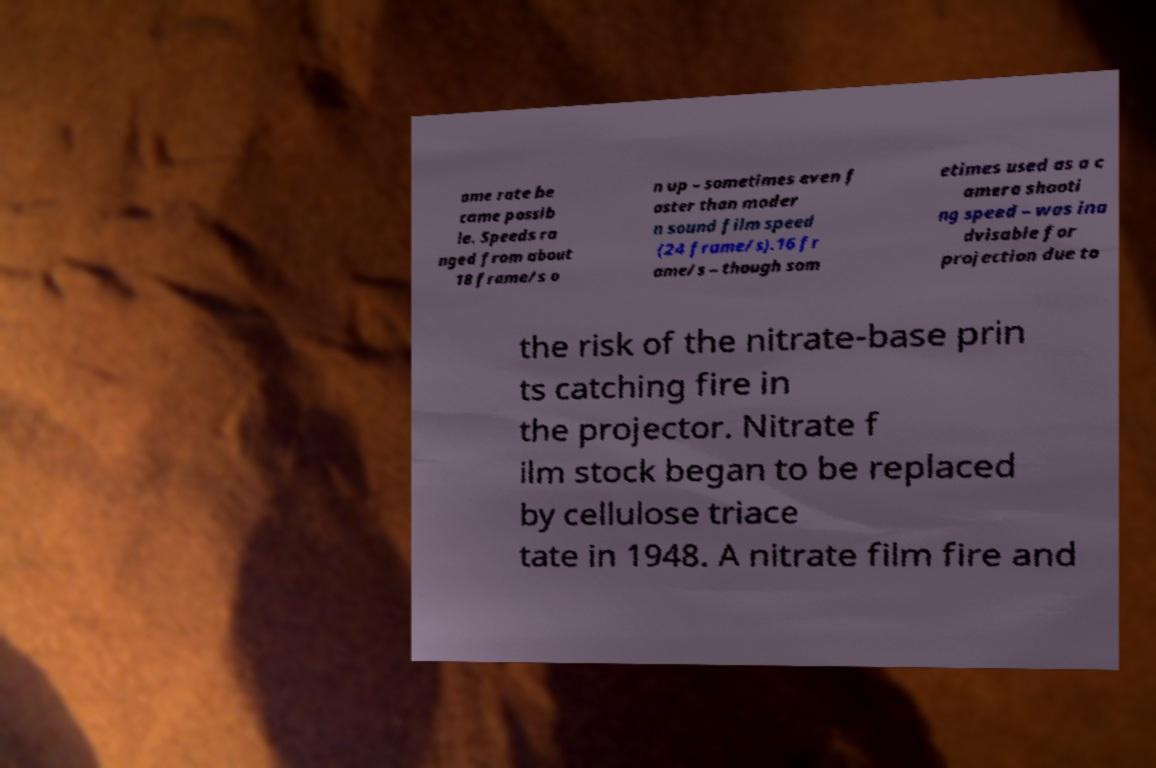Can you read and provide the text displayed in the image?This photo seems to have some interesting text. Can you extract and type it out for me? ame rate be came possib le. Speeds ra nged from about 18 frame/s o n up – sometimes even f aster than moder n sound film speed (24 frame/s).16 fr ame/s – though som etimes used as a c amera shooti ng speed – was ina dvisable for projection due to the risk of the nitrate-base prin ts catching fire in the projector. Nitrate f ilm stock began to be replaced by cellulose triace tate in 1948. A nitrate film fire and 